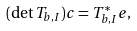<formula> <loc_0><loc_0><loc_500><loc_500>( \det T _ { b , I } ) c = T _ { b , I } ^ { * } e ,</formula> 